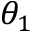Convert formula to latex. <formula><loc_0><loc_0><loc_500><loc_500>\theta _ { 1 }</formula> 